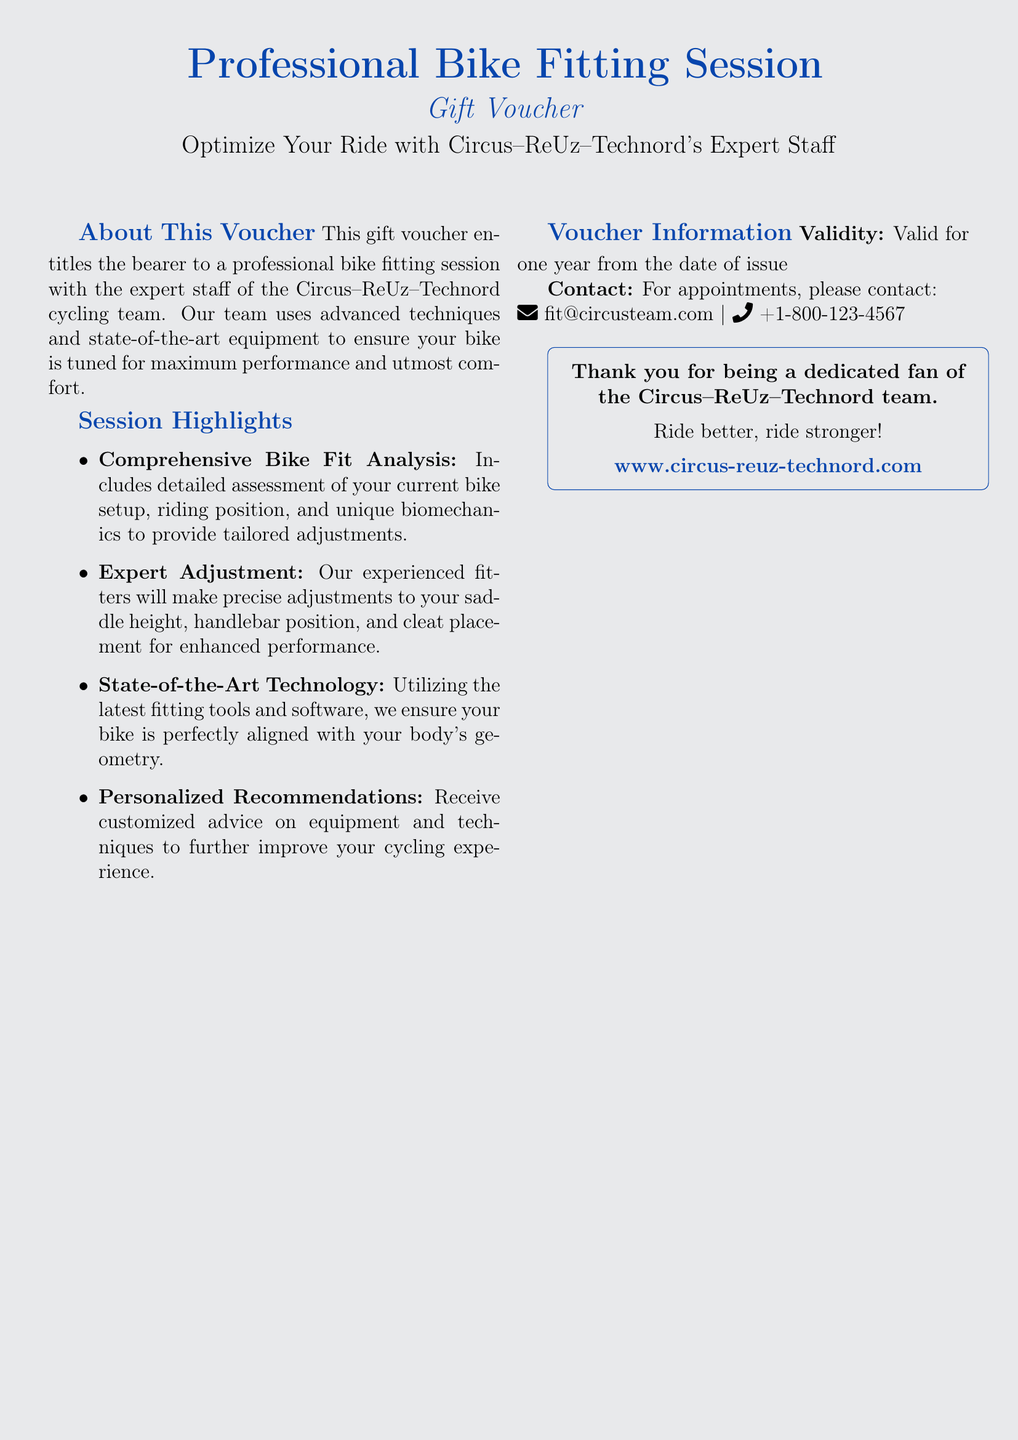What is the title of the voucher? The title of the voucher is prominently displayed at the top of the document.
Answer: Professional Bike Fitting Session Who is providing the bike fitting service? The document specifies the cycling team offering the service.
Answer: Circus–ReUz–Technord What is the validity period of the voucher? The voucher mentions the duration it can be used in its details section.
Answer: One year What type of analysis is included in the session? The document outlines specific features included in the fitting session.
Answer: Comprehensive Bike Fit Analysis What should you do to make an appointment? The document provides contact methods for setting up the fitting session.
Answer: Contact fit@circusteam.com or +1-800-123-4567 What will the expert adjustment improve? The document lists the adjustments that will be made during the fitting session.
Answer: Performance What is the primary objective of the bike fitting session? The main purpose of the service is stated in the introduction of the voucher.
Answer: Optimize Your Ride What are the bike fitting experts using for their service? The document mentions the tools and equipment used during the fitting.
Answer: State-of-the-Art Technology How does the document thank the fan? The conclusion of the document includes a message directed at supporters.
Answer: Thank you for being a dedicated fan of the Circus–ReUz–Technord team 